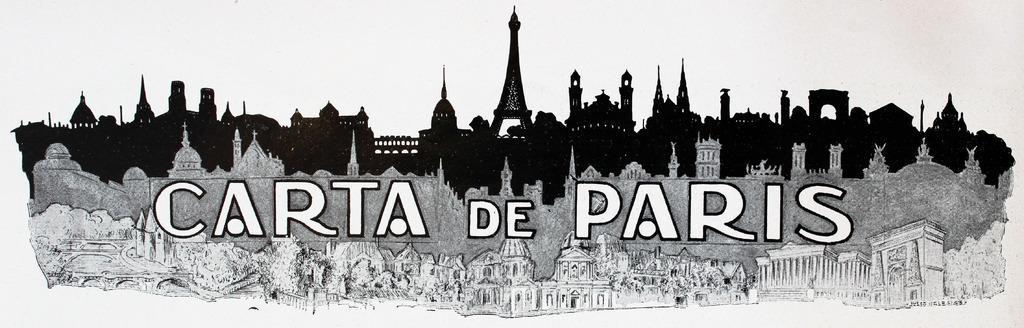Could you give a brief overview of what you see in this image? It looks like a black and white animated picture of buildings and on the animated picture it is written something. Behind the buildings there is the white background. 